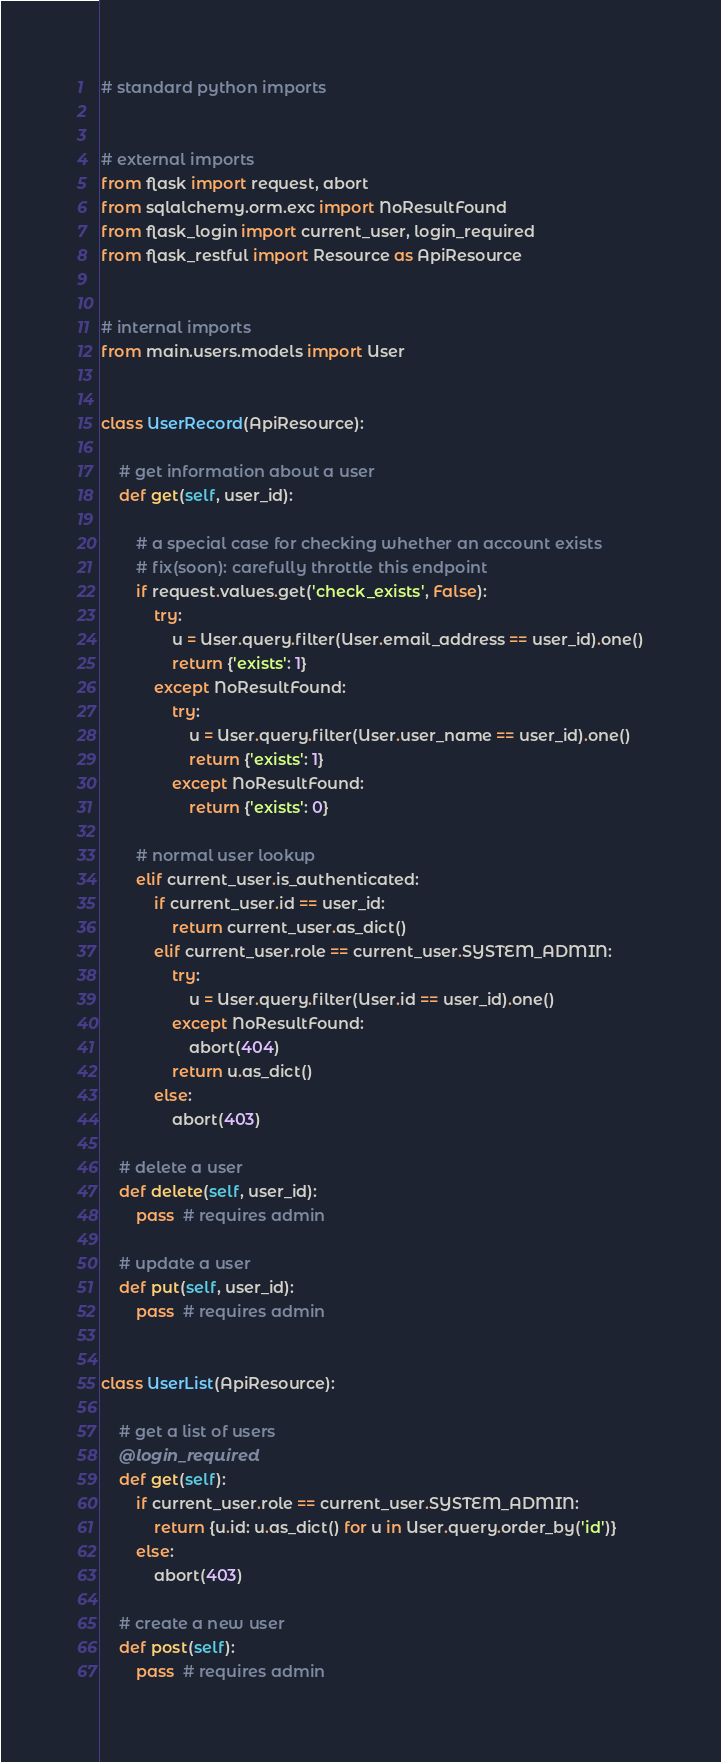<code> <loc_0><loc_0><loc_500><loc_500><_Python_># standard python imports


# external imports
from flask import request, abort
from sqlalchemy.orm.exc import NoResultFound
from flask_login import current_user, login_required
from flask_restful import Resource as ApiResource


# internal imports
from main.users.models import User


class UserRecord(ApiResource):

    # get information about a user
    def get(self, user_id):

        # a special case for checking whether an account exists
        # fix(soon): carefully throttle this endpoint
        if request.values.get('check_exists', False):
            try:
                u = User.query.filter(User.email_address == user_id).one()
                return {'exists': 1}
            except NoResultFound:
                try:
                    u = User.query.filter(User.user_name == user_id).one()
                    return {'exists': 1}
                except NoResultFound:
                    return {'exists': 0}

        # normal user lookup
        elif current_user.is_authenticated:
            if current_user.id == user_id:
                return current_user.as_dict()
            elif current_user.role == current_user.SYSTEM_ADMIN:
                try:
                    u = User.query.filter(User.id == user_id).one()
                except NoResultFound:
                    abort(404)
                return u.as_dict()
            else:
                abort(403)

    # delete a user
    def delete(self, user_id):
        pass  # requires admin

    # update a user
    def put(self, user_id):
        pass  # requires admin


class UserList(ApiResource):

    # get a list of users
    @login_required
    def get(self):
        if current_user.role == current_user.SYSTEM_ADMIN:
            return {u.id: u.as_dict() for u in User.query.order_by('id')}
        else:
            abort(403)

    # create a new user
    def post(self):
        pass  # requires admin
</code> 